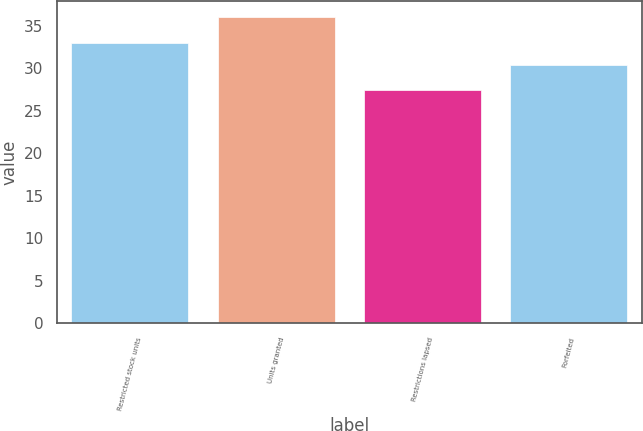Convert chart. <chart><loc_0><loc_0><loc_500><loc_500><bar_chart><fcel>Restricted stock units<fcel>Units granted<fcel>Restrictions lapsed<fcel>Forfeited<nl><fcel>33.01<fcel>36.05<fcel>27.48<fcel>30.37<nl></chart> 